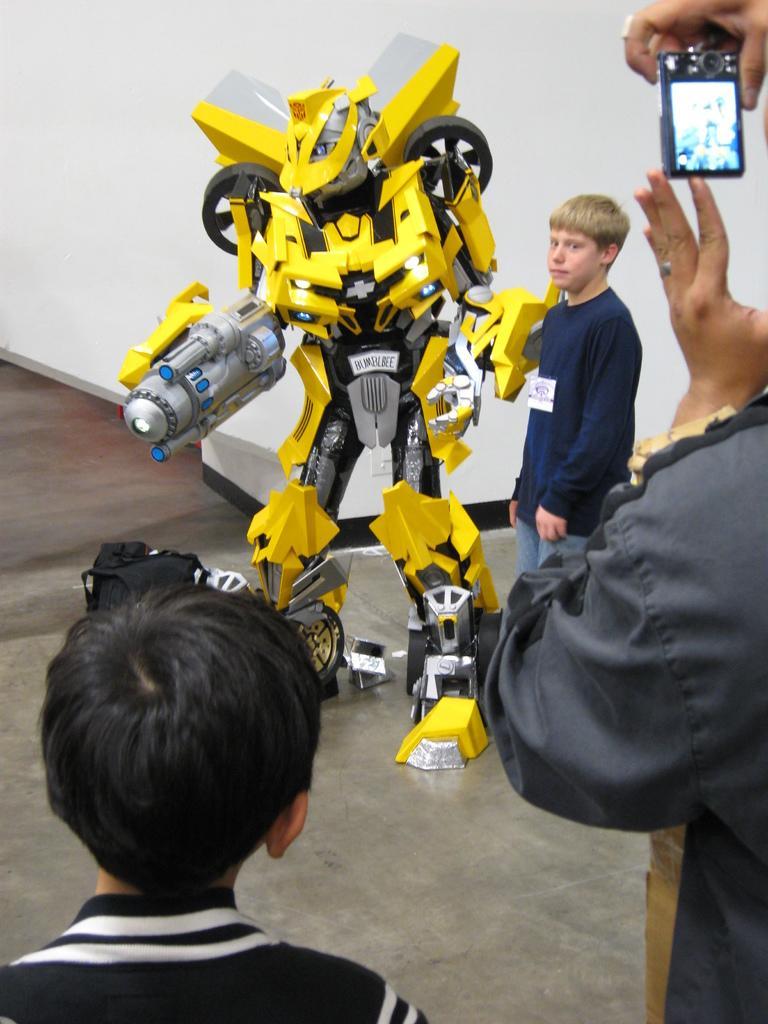Can you describe this image briefly? In the foreground of the picture we can see a kid and a person. The person is holding a camera. In the center of the picture we can see a robot and a person. In the background there is wall. On the left it is floor. 